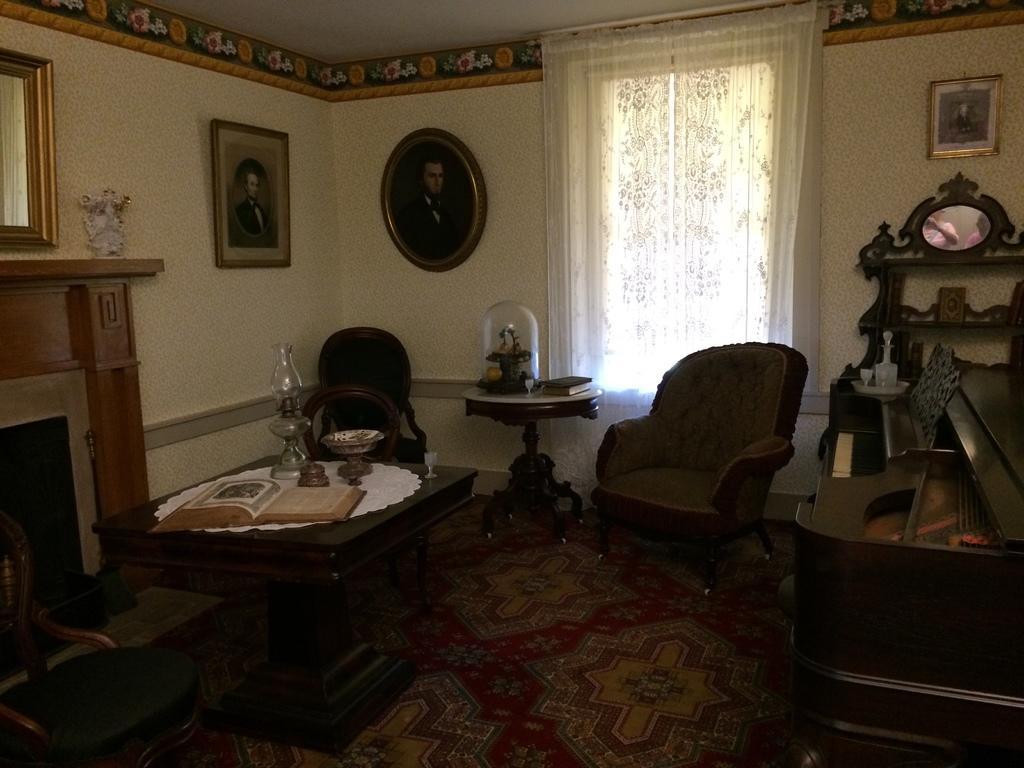Describe this image in one or two sentences. This picture is taken inside a room where I can see the table on which I can see book and few more objects are placed, I can see chairs, few more objects on the right side of the image, I can see fireplace, photo frames on the wall on the left side of the image and I can see curtains in the background of the image. 